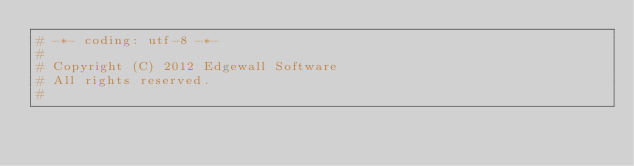<code> <loc_0><loc_0><loc_500><loc_500><_Python_># -*- coding: utf-8 -*-
#
# Copyright (C) 2012 Edgewall Software
# All rights reserved.
#</code> 